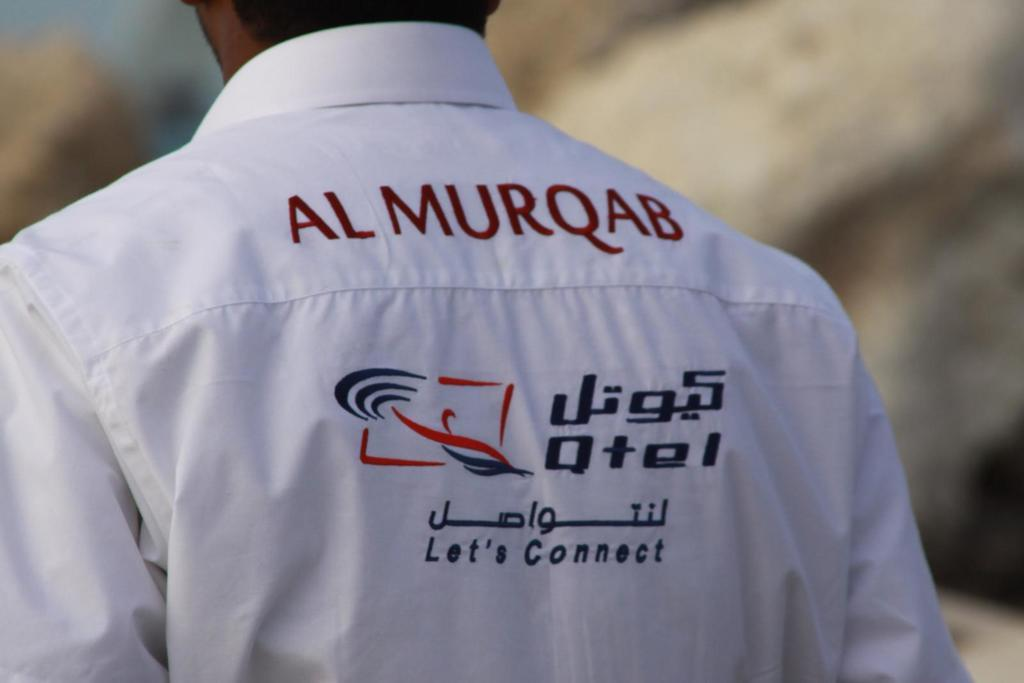<image>
Relay a brief, clear account of the picture shown. Man wearing a shirt that says "Al Murqab" on the back. 